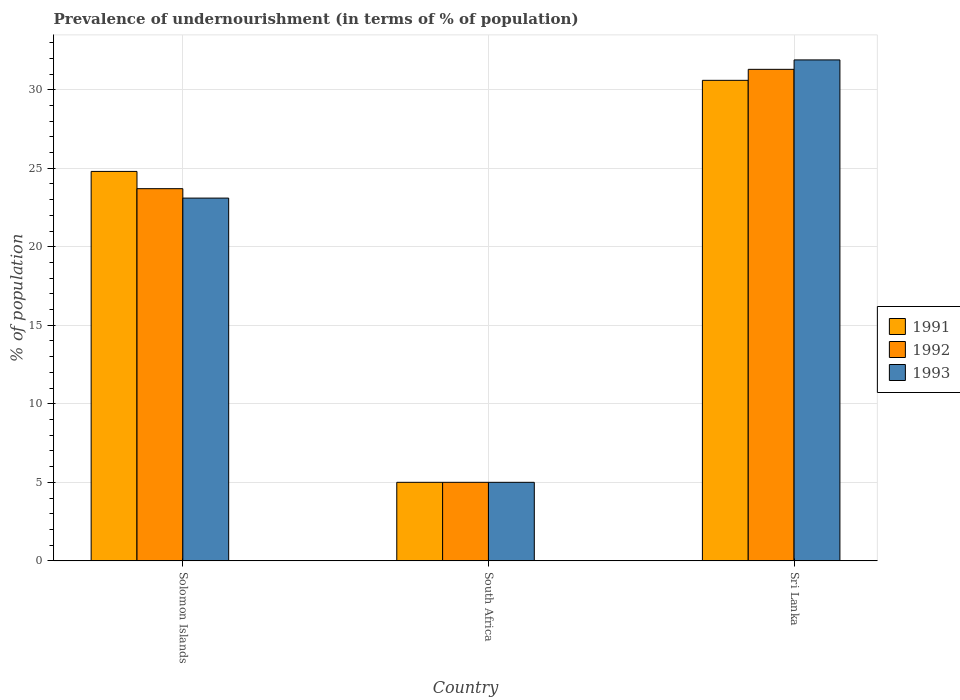What is the label of the 1st group of bars from the left?
Ensure brevity in your answer.  Solomon Islands. In how many cases, is the number of bars for a given country not equal to the number of legend labels?
Offer a very short reply. 0. What is the percentage of undernourished population in 1993 in Sri Lanka?
Ensure brevity in your answer.  31.9. Across all countries, what is the maximum percentage of undernourished population in 1991?
Your response must be concise. 30.6. Across all countries, what is the minimum percentage of undernourished population in 1991?
Offer a terse response. 5. In which country was the percentage of undernourished population in 1993 maximum?
Your response must be concise. Sri Lanka. In which country was the percentage of undernourished population in 1992 minimum?
Give a very brief answer. South Africa. What is the total percentage of undernourished population in 1991 in the graph?
Your answer should be very brief. 60.4. What is the difference between the percentage of undernourished population in 1993 in Solomon Islands and that in South Africa?
Provide a short and direct response. 18.1. What is the difference between the percentage of undernourished population in 1993 in Sri Lanka and the percentage of undernourished population in 1992 in South Africa?
Give a very brief answer. 26.9. What is the difference between the percentage of undernourished population of/in 1992 and percentage of undernourished population of/in 1991 in Sri Lanka?
Make the answer very short. 0.7. What is the ratio of the percentage of undernourished population in 1992 in South Africa to that in Sri Lanka?
Offer a terse response. 0.16. Is the difference between the percentage of undernourished population in 1992 in Solomon Islands and Sri Lanka greater than the difference between the percentage of undernourished population in 1991 in Solomon Islands and Sri Lanka?
Make the answer very short. No. What is the difference between the highest and the lowest percentage of undernourished population in 1991?
Your answer should be compact. 25.6. In how many countries, is the percentage of undernourished population in 1993 greater than the average percentage of undernourished population in 1993 taken over all countries?
Your answer should be very brief. 2. What does the 1st bar from the left in South Africa represents?
Keep it short and to the point. 1991. What does the 2nd bar from the right in South Africa represents?
Give a very brief answer. 1992. Are all the bars in the graph horizontal?
Ensure brevity in your answer.  No. How many countries are there in the graph?
Ensure brevity in your answer.  3. Are the values on the major ticks of Y-axis written in scientific E-notation?
Provide a succinct answer. No. How many legend labels are there?
Your answer should be very brief. 3. What is the title of the graph?
Your answer should be compact. Prevalence of undernourishment (in terms of % of population). What is the label or title of the X-axis?
Ensure brevity in your answer.  Country. What is the label or title of the Y-axis?
Provide a succinct answer. % of population. What is the % of population in 1991 in Solomon Islands?
Provide a succinct answer. 24.8. What is the % of population of 1992 in Solomon Islands?
Ensure brevity in your answer.  23.7. What is the % of population in 1993 in Solomon Islands?
Ensure brevity in your answer.  23.1. What is the % of population in 1991 in South Africa?
Make the answer very short. 5. What is the % of population of 1993 in South Africa?
Ensure brevity in your answer.  5. What is the % of population of 1991 in Sri Lanka?
Your answer should be compact. 30.6. What is the % of population in 1992 in Sri Lanka?
Make the answer very short. 31.3. What is the % of population in 1993 in Sri Lanka?
Keep it short and to the point. 31.9. Across all countries, what is the maximum % of population of 1991?
Offer a terse response. 30.6. Across all countries, what is the maximum % of population of 1992?
Your answer should be very brief. 31.3. Across all countries, what is the maximum % of population of 1993?
Your response must be concise. 31.9. Across all countries, what is the minimum % of population in 1991?
Your answer should be very brief. 5. Across all countries, what is the minimum % of population of 1992?
Your response must be concise. 5. What is the total % of population of 1991 in the graph?
Your answer should be very brief. 60.4. What is the total % of population of 1993 in the graph?
Give a very brief answer. 60. What is the difference between the % of population in 1991 in Solomon Islands and that in South Africa?
Your answer should be very brief. 19.8. What is the difference between the % of population in 1992 in Solomon Islands and that in South Africa?
Make the answer very short. 18.7. What is the difference between the % of population of 1991 in Solomon Islands and that in Sri Lanka?
Your answer should be very brief. -5.8. What is the difference between the % of population in 1992 in Solomon Islands and that in Sri Lanka?
Offer a very short reply. -7.6. What is the difference between the % of population of 1993 in Solomon Islands and that in Sri Lanka?
Provide a short and direct response. -8.8. What is the difference between the % of population in 1991 in South Africa and that in Sri Lanka?
Provide a short and direct response. -25.6. What is the difference between the % of population of 1992 in South Africa and that in Sri Lanka?
Ensure brevity in your answer.  -26.3. What is the difference between the % of population of 1993 in South Africa and that in Sri Lanka?
Your answer should be compact. -26.9. What is the difference between the % of population in 1991 in Solomon Islands and the % of population in 1992 in South Africa?
Your answer should be very brief. 19.8. What is the difference between the % of population in 1991 in Solomon Islands and the % of population in 1993 in South Africa?
Provide a short and direct response. 19.8. What is the difference between the % of population of 1991 in Solomon Islands and the % of population of 1992 in Sri Lanka?
Provide a succinct answer. -6.5. What is the difference between the % of population of 1991 in Solomon Islands and the % of population of 1993 in Sri Lanka?
Make the answer very short. -7.1. What is the difference between the % of population in 1992 in Solomon Islands and the % of population in 1993 in Sri Lanka?
Your answer should be very brief. -8.2. What is the difference between the % of population of 1991 in South Africa and the % of population of 1992 in Sri Lanka?
Offer a very short reply. -26.3. What is the difference between the % of population in 1991 in South Africa and the % of population in 1993 in Sri Lanka?
Provide a succinct answer. -26.9. What is the difference between the % of population of 1992 in South Africa and the % of population of 1993 in Sri Lanka?
Provide a short and direct response. -26.9. What is the average % of population of 1991 per country?
Offer a very short reply. 20.13. What is the average % of population of 1993 per country?
Ensure brevity in your answer.  20. What is the difference between the % of population in 1992 and % of population in 1993 in Solomon Islands?
Offer a very short reply. 0.6. What is the difference between the % of population of 1991 and % of population of 1993 in South Africa?
Your answer should be compact. 0. What is the difference between the % of population in 1992 and % of population in 1993 in South Africa?
Ensure brevity in your answer.  0. What is the difference between the % of population in 1991 and % of population in 1992 in Sri Lanka?
Ensure brevity in your answer.  -0.7. What is the ratio of the % of population of 1991 in Solomon Islands to that in South Africa?
Your answer should be very brief. 4.96. What is the ratio of the % of population of 1992 in Solomon Islands to that in South Africa?
Your answer should be very brief. 4.74. What is the ratio of the % of population in 1993 in Solomon Islands to that in South Africa?
Make the answer very short. 4.62. What is the ratio of the % of population of 1991 in Solomon Islands to that in Sri Lanka?
Offer a terse response. 0.81. What is the ratio of the % of population of 1992 in Solomon Islands to that in Sri Lanka?
Provide a short and direct response. 0.76. What is the ratio of the % of population in 1993 in Solomon Islands to that in Sri Lanka?
Your response must be concise. 0.72. What is the ratio of the % of population in 1991 in South Africa to that in Sri Lanka?
Ensure brevity in your answer.  0.16. What is the ratio of the % of population of 1992 in South Africa to that in Sri Lanka?
Provide a succinct answer. 0.16. What is the ratio of the % of population in 1993 in South Africa to that in Sri Lanka?
Give a very brief answer. 0.16. What is the difference between the highest and the lowest % of population in 1991?
Make the answer very short. 25.6. What is the difference between the highest and the lowest % of population in 1992?
Your answer should be compact. 26.3. What is the difference between the highest and the lowest % of population of 1993?
Provide a short and direct response. 26.9. 